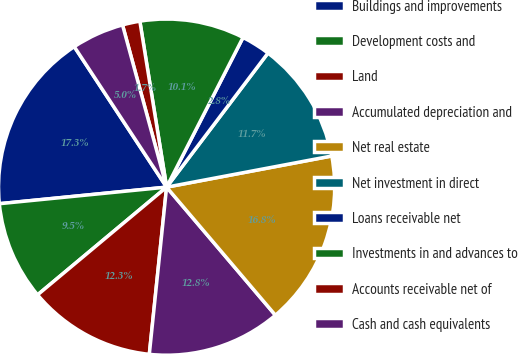Convert chart to OTSL. <chart><loc_0><loc_0><loc_500><loc_500><pie_chart><fcel>Buildings and improvements<fcel>Development costs and<fcel>Land<fcel>Accumulated depreciation and<fcel>Net real estate<fcel>Net investment in direct<fcel>Loans receivable net<fcel>Investments in and advances to<fcel>Accounts receivable net of<fcel>Cash and cash equivalents<nl><fcel>17.32%<fcel>9.5%<fcel>12.29%<fcel>12.85%<fcel>16.76%<fcel>11.73%<fcel>2.79%<fcel>10.06%<fcel>1.68%<fcel>5.03%<nl></chart> 